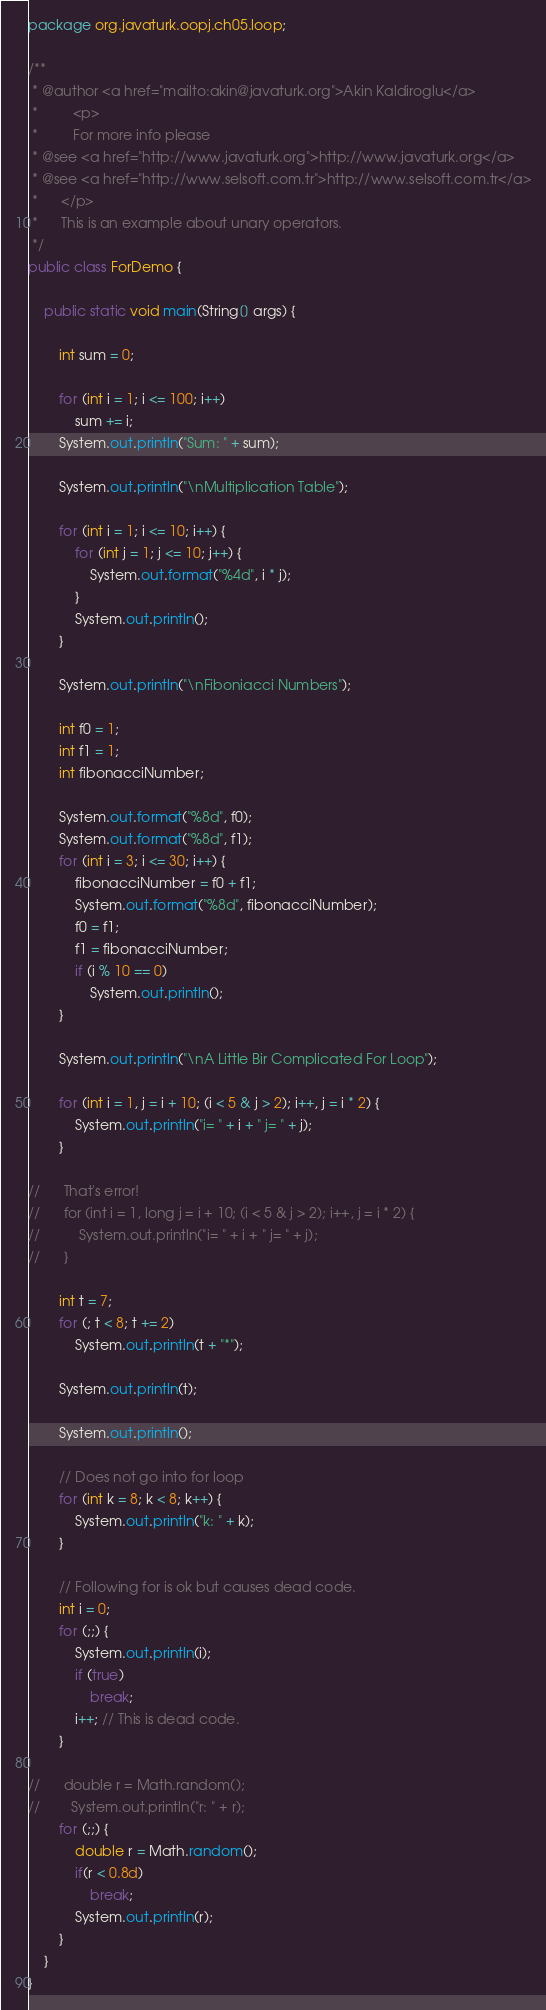<code> <loc_0><loc_0><loc_500><loc_500><_Java_>package org.javaturk.oopj.ch05.loop;

/**
 * @author <a href="mailto:akin@javaturk.org">Akin Kaldiroglu</a>
 *         <p>
 *         For more info please
 * @see <a href="http://www.javaturk.org">http://www.javaturk.org</a>
 * @see <a href="http://www.selsoft.com.tr">http://www.selsoft.com.tr</a>
 *      </p>
 *      This is an example about unary operators.
 */
public class ForDemo {

	public static void main(String[] args) {

		int sum = 0;

		for (int i = 1; i <= 100; i++)
			sum += i;
		System.out.println("Sum: " + sum);

		System.out.println("\nMultiplication Table");

		for (int i = 1; i <= 10; i++) {
			for (int j = 1; j <= 10; j++) {
				System.out.format("%4d", i * j);
			}
			System.out.println();
		}

		System.out.println("\nFiboniacci Numbers");

		int f0 = 1;
		int f1 = 1;
		int fibonacciNumber;

		System.out.format("%8d", f0);
		System.out.format("%8d", f1);
		for (int i = 3; i <= 30; i++) {
			fibonacciNumber = f0 + f1;
			System.out.format("%8d", fibonacciNumber);
			f0 = f1;
			f1 = fibonacciNumber;
			if (i % 10 == 0)
				System.out.println();
		}

		System.out.println("\nA Little Bir Complicated For Loop");

		for (int i = 1, j = i + 10; (i < 5 & j > 2); i++, j = i * 2) {
			System.out.println("i= " + i + " j= " + j);
		}

//		That's error!
//		for (int i = 1, long j = i + 10; (i < 5 & j > 2); i++, j = i * 2) {
//			System.out.println("i= " + i + " j= " + j);
//		}
		
		int t = 7;
		for (; t < 8; t += 2)
			System.out.println(t + "*");

		System.out.println(t);
		
		System.out.println();

		// Does not go into for loop
		for (int k = 8; k < 8; k++) {
			System.out.println("k: " + k);
		}

		// Following for is ok but causes dead code.
		int i = 0;
		for (;;) {
			System.out.println(i);
			if (true)
				break;
			i++; // This is dead code.
		}
		
//		double r = Math.random();
//        System.out.println("r: " + r);
        for (;;) {
        	double r = Math.random();
        	if(r < 0.8d)
        		break;
        	System.out.println(r);
        }
	}
}
</code> 